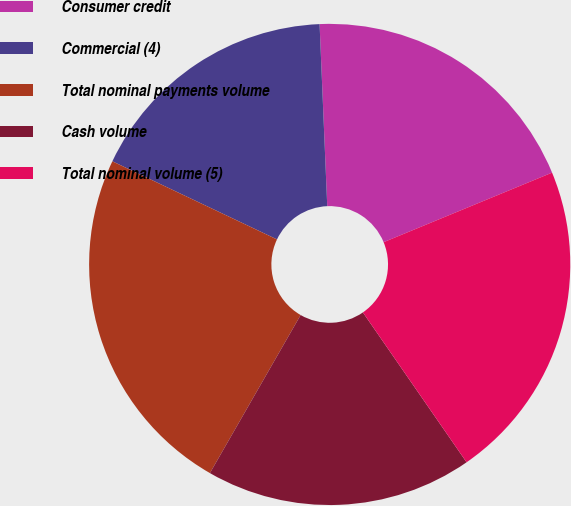Convert chart to OTSL. <chart><loc_0><loc_0><loc_500><loc_500><pie_chart><fcel>Consumer credit<fcel>Commercial (4)<fcel>Total nominal payments volume<fcel>Cash volume<fcel>Total nominal volume (5)<nl><fcel>19.44%<fcel>17.28%<fcel>23.76%<fcel>17.93%<fcel>21.6%<nl></chart> 